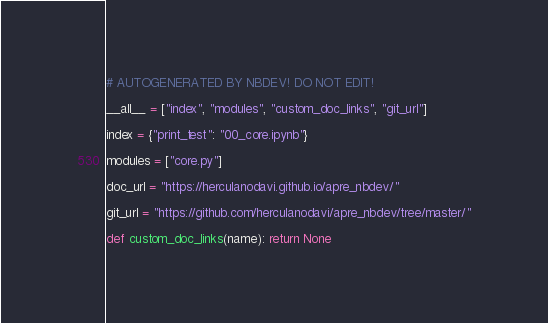Convert code to text. <code><loc_0><loc_0><loc_500><loc_500><_Python_># AUTOGENERATED BY NBDEV! DO NOT EDIT!

__all__ = ["index", "modules", "custom_doc_links", "git_url"]

index = {"print_test": "00_core.ipynb"}

modules = ["core.py"]

doc_url = "https://herculanodavi.github.io/apre_nbdev/"

git_url = "https://github.com/herculanodavi/apre_nbdev/tree/master/"

def custom_doc_links(name): return None
</code> 